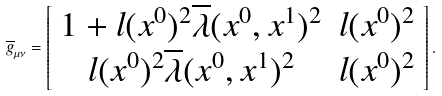<formula> <loc_0><loc_0><loc_500><loc_500>\overline { g } _ { \mu \nu } = \left [ \begin{array} { c c } 1 + l ( x ^ { 0 } ) ^ { 2 } \overline { \lambda } ( x ^ { 0 } , x ^ { 1 } ) ^ { 2 } & l ( x ^ { 0 } ) ^ { 2 } \\ l ( x ^ { 0 } ) ^ { 2 } \overline { \lambda } ( x ^ { 0 } , x ^ { 1 } ) ^ { 2 } & l ( x ^ { 0 } ) ^ { 2 } \end{array} \right ] .</formula> 